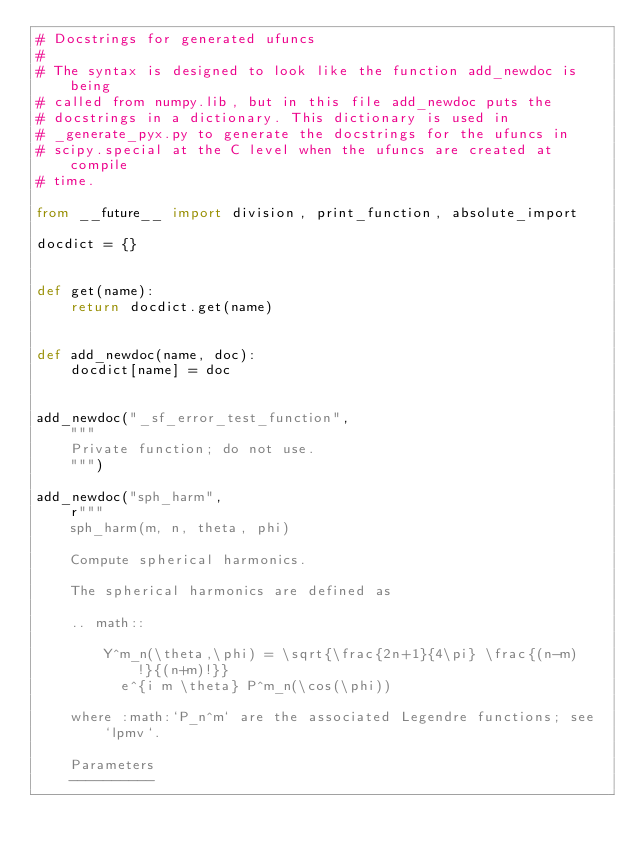Convert code to text. <code><loc_0><loc_0><loc_500><loc_500><_Python_># Docstrings for generated ufuncs
#
# The syntax is designed to look like the function add_newdoc is being
# called from numpy.lib, but in this file add_newdoc puts the
# docstrings in a dictionary. This dictionary is used in
# _generate_pyx.py to generate the docstrings for the ufuncs in
# scipy.special at the C level when the ufuncs are created at compile
# time.

from __future__ import division, print_function, absolute_import

docdict = {}


def get(name):
    return docdict.get(name)


def add_newdoc(name, doc):
    docdict[name] = doc


add_newdoc("_sf_error_test_function",
    """
    Private function; do not use.
    """)

add_newdoc("sph_harm",
    r"""
    sph_harm(m, n, theta, phi)

    Compute spherical harmonics.

    The spherical harmonics are defined as

    .. math::

        Y^m_n(\theta,\phi) = \sqrt{\frac{2n+1}{4\pi} \frac{(n-m)!}{(n+m)!}}
          e^{i m \theta} P^m_n(\cos(\phi))

    where :math:`P_n^m` are the associated Legendre functions; see `lpmv`.

    Parameters
    ----------</code> 